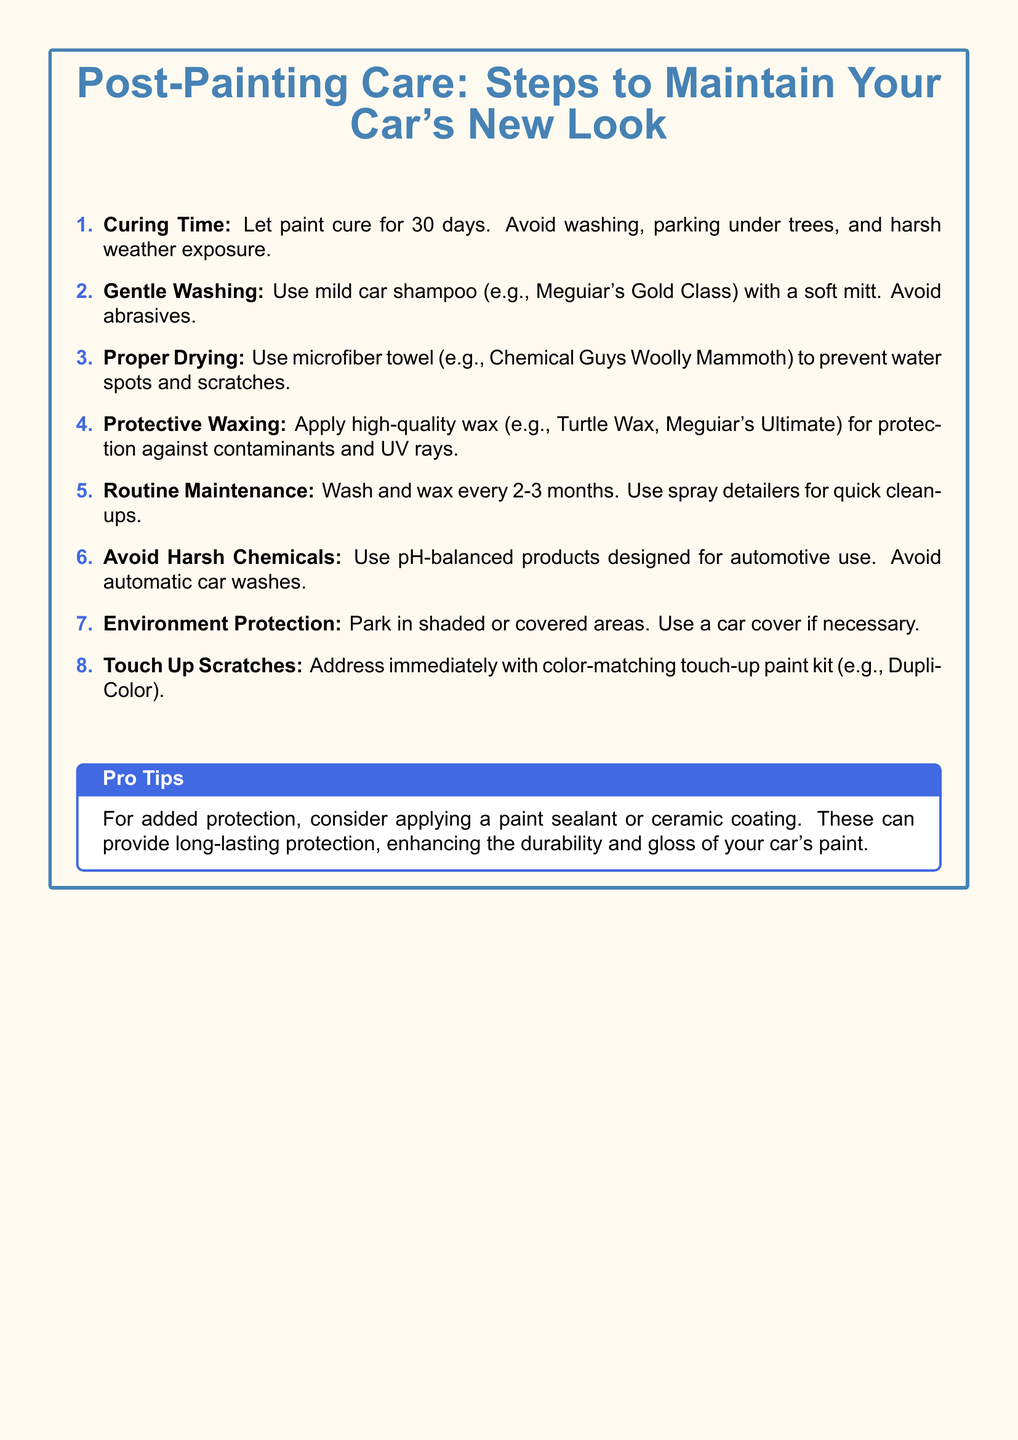What is the curing time for the paint? The curing time mentioned in the document is specified as 30 days.
Answer: 30 days What should you avoid during the curing time? The document lists washing, parking under trees, and harsh weather exposure as activities to avoid.
Answer: washing, parking under trees, and harsh weather exposure What type of towel is recommended for drying? The document suggests using a microfiber towel to prevent water spots and scratches.
Answer: microfiber towel How often should you wash and wax your car? The document states that washing and waxing should be done every 2-3 months.
Answer: every 2-3 months What type of products should be avoided? The document advises avoiding harsh chemicals that are not pH-balanced and automatic car washes.
Answer: harsh chemicals What should you do if you notice scratches? The document recommends addressing scratches immediately with a color-matching touch-up paint kit.
Answer: color-matching touch-up paint kit What is a recommended car wax mentioned in the document? The document mentions Turtle Wax and Meguiar's Ultimate as high-quality wax options.
Answer: Turtle Wax, Meguiar's Ultimate What additional protection options are suggested in the Pro Tips? The Pro Tips section suggests considering paint sealants or ceramic coatings for added protection.
Answer: paint sealants or ceramic coatings 